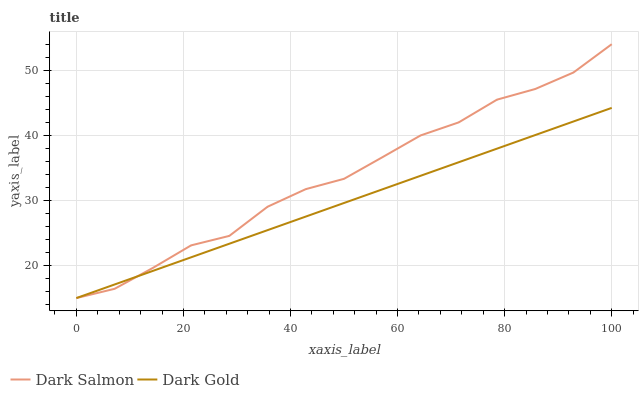Does Dark Gold have the minimum area under the curve?
Answer yes or no. Yes. Does Dark Salmon have the maximum area under the curve?
Answer yes or no. Yes. Does Dark Gold have the maximum area under the curve?
Answer yes or no. No. Is Dark Gold the smoothest?
Answer yes or no. Yes. Is Dark Salmon the roughest?
Answer yes or no. Yes. Is Dark Gold the roughest?
Answer yes or no. No. Does Dark Salmon have the lowest value?
Answer yes or no. Yes. Does Dark Salmon have the highest value?
Answer yes or no. Yes. Does Dark Gold have the highest value?
Answer yes or no. No. Does Dark Gold intersect Dark Salmon?
Answer yes or no. Yes. Is Dark Gold less than Dark Salmon?
Answer yes or no. No. Is Dark Gold greater than Dark Salmon?
Answer yes or no. No. 